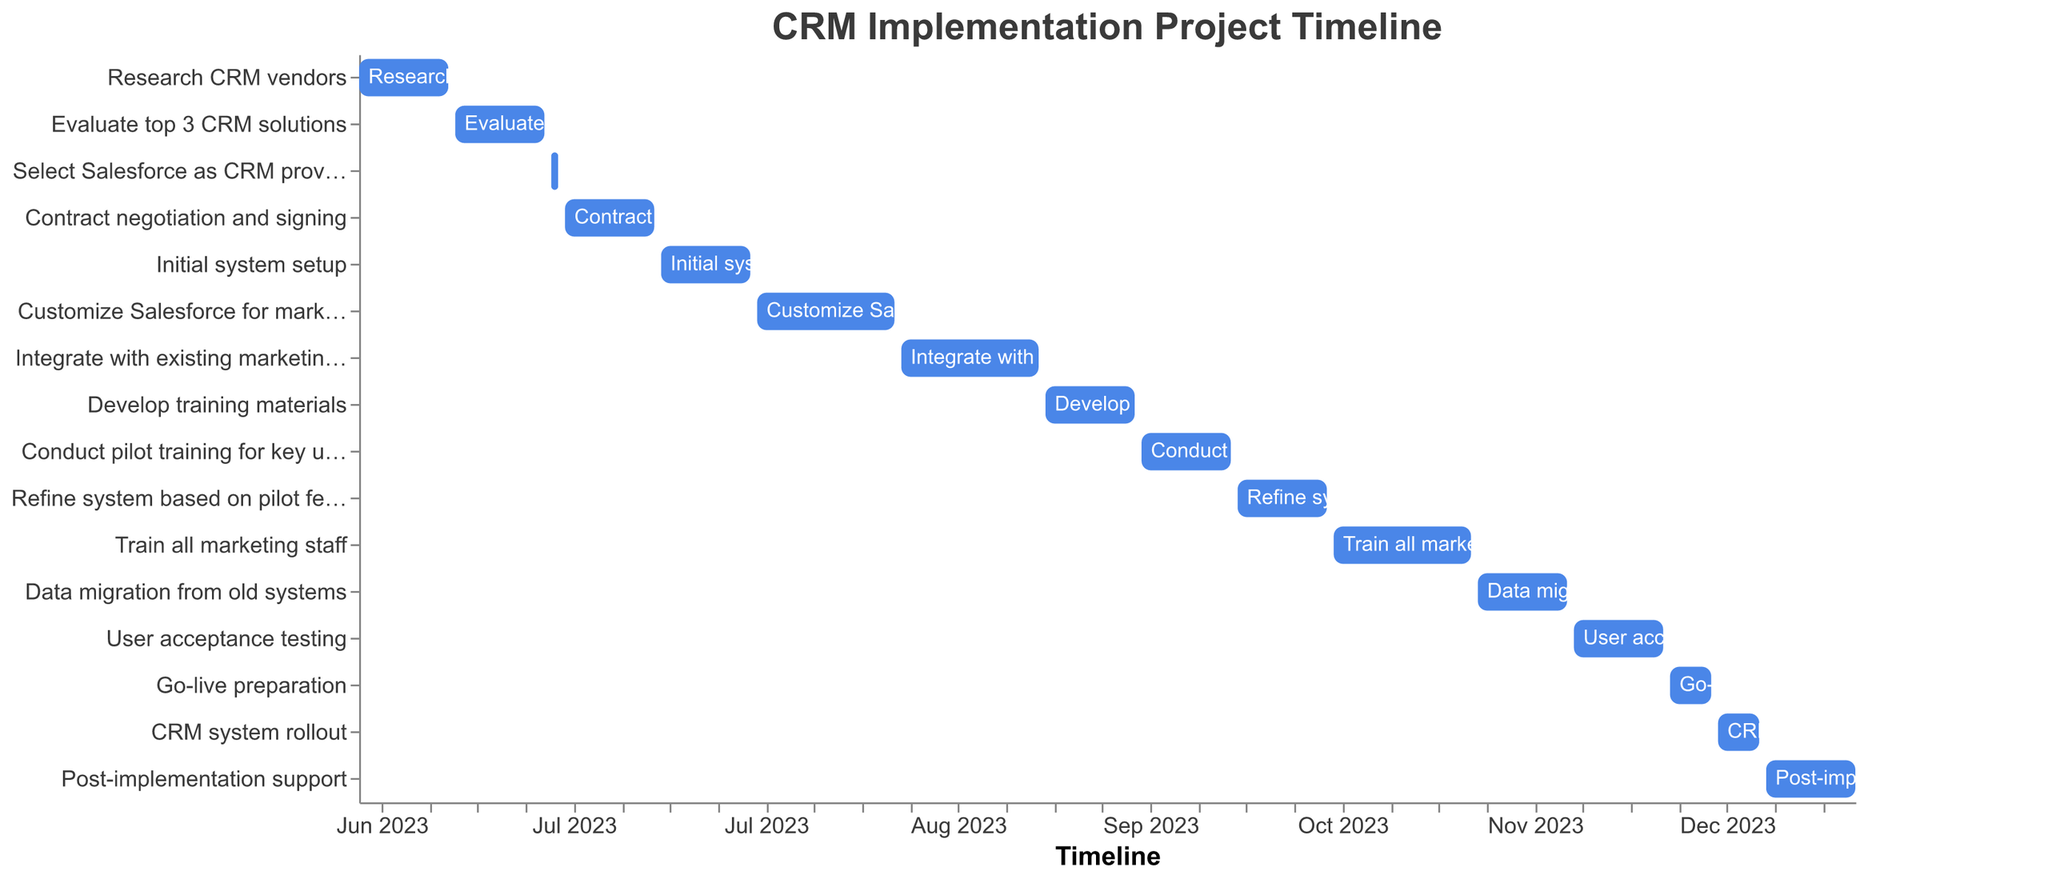What's the title of the Gantt Chart? The title is usually displayed at the top of the Gantt Chart. Here, it reads "CRM Implementation Project Timeline".
Answer: CRM Implementation Project Timeline What is the starting date for the "Select Salesforce as CRM provider" task? Look at the bar representing the "Select Salesforce as CRM provider" task and note its starting position on the timeline. According to the data, it starts on June 29, 2023.
Answer: June 29, 2023 How long does the "Customize Salesforce for marketing needs" task last? Subtract the start date from the end date for the "Customize Salesforce for marketing needs" task. The task lasts from July 29, 2023, to August 18, 2023. That's 21 days.
Answer: 21 days What tasks are scheduled to be completed by the end of August 2023? Check the timeline for bars ending in August 2023 or earlier. Tasks ending by August 2023 are "Customize Salesforce for marketing needs" (ends August 18) and all tasks before it.
Answer: Customize Salesforce for marketing needs and earlier tasks Which task spans the longest duration? Compare the duration of each task visually or calculate the difference between the start and end dates for each task. "Train all marketing staff" lasts from October 21, 2023, to November 10, 2023, which is 21 days. Verify if this is the longest duration by comparing it to others.
Answer: Train all marketing staff When does the "Post-implementation support" task begin? Locate the bar representing "Post-implementation support" and take note of its start date, which is December 23, 2023.
Answer: December 23, 2023 How many tasks are completed before the end of September 2023? Identify all tasks with end dates before September 2023. They are: "Research CRM vendors", "Evaluate top 3 CRM solutions", "Select Salesforce as CRM provider", "Contract negotiation and signing", "Initial system setup", "Customize Salesforce for marketing needs", and "Integrate with existing marketing tools". That's 7 tasks.
Answer: 7 tasks Which tasks overlap with the "Develop training materials" task? Find tasks that start before or during the "Develop training materials" task and end after it starts or during it. These tasks are: "Integrate with existing marketing tools" (ends September 8) and "Conduct pilot training for key users" (starts September 23).
Answer: Integrate with existing marketing tools, Conduct pilot training for key users Compare the start and end dates of the "User acceptance testing" and "Go-live preparation" tasks. Which one starts first? Check the start date of "User acceptance testing" (November 25, 2023) and "Go-live preparation" (December 9, 2023). "User acceptance testing" starts earlier.
Answer: User acceptance testing Which phase follows the "CRM system rollout"? Look at the sequence of tasks. The task after "CRM system rollout" (ending December 22, 2023) is "Post-implementation support" starting December 23, 2023.
Answer: Post-implementation support 